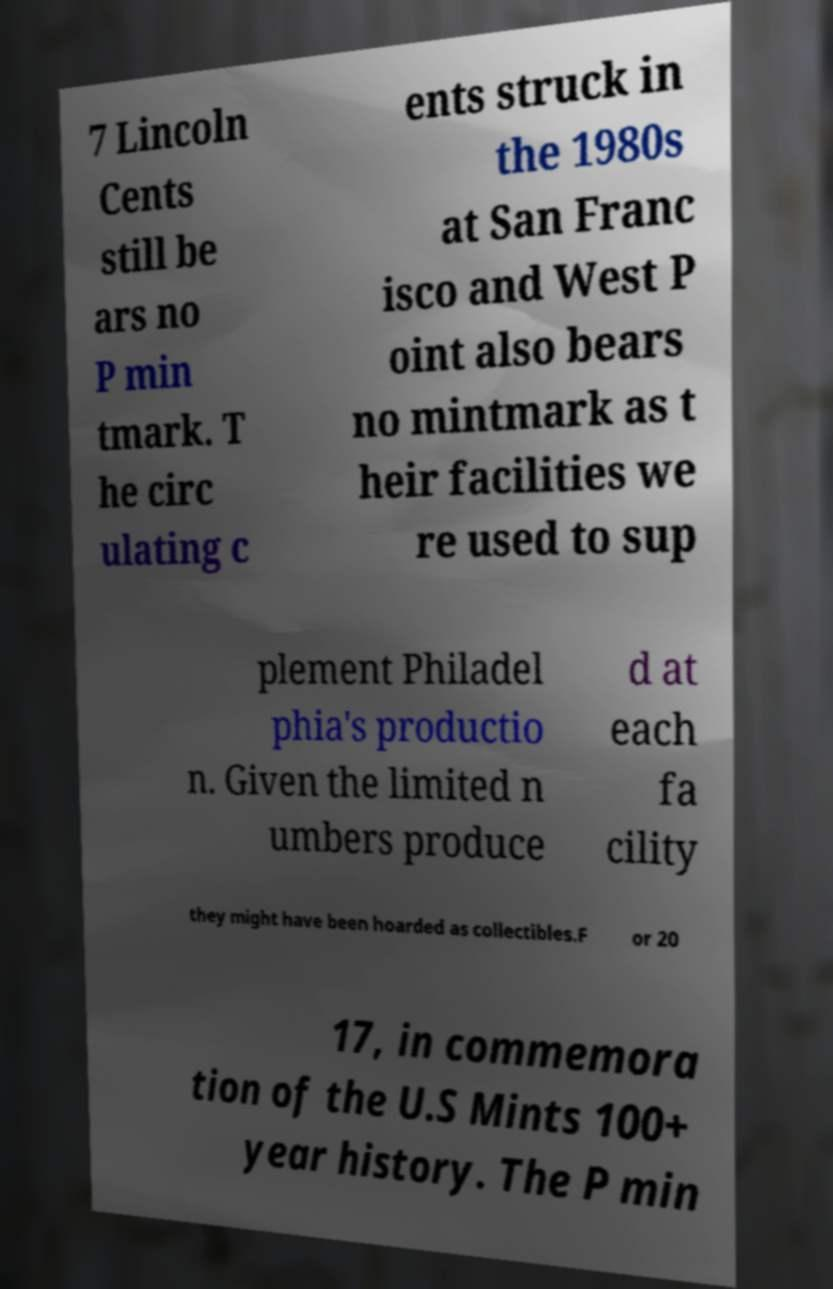What messages or text are displayed in this image? I need them in a readable, typed format. 7 Lincoln Cents still be ars no P min tmark. T he circ ulating c ents struck in the 1980s at San Franc isco and West P oint also bears no mintmark as t heir facilities we re used to sup plement Philadel phia's productio n. Given the limited n umbers produce d at each fa cility they might have been hoarded as collectibles.F or 20 17, in commemora tion of the U.S Mints 100+ year history. The P min 